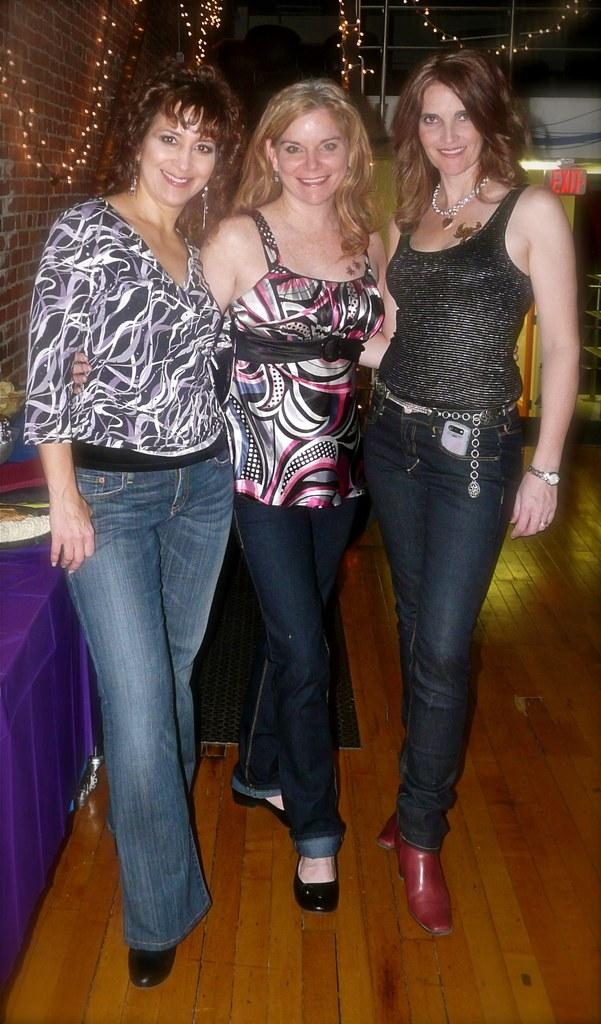What are the women in the image doing? The women in the image are standing and smiling in the center of the image. What can be seen on the left side of the image? There is a table on the left side of the image. What is visible in the background of the image? There are lights and some text written on a board in the background of the image. How many clovers are on the table in the image? There are no clovers present in the image; the table is on the left side of the image. What subject is the woman teaching in the image? There is no woman teaching in the image; the women are standing and smiling in the center of the image. 